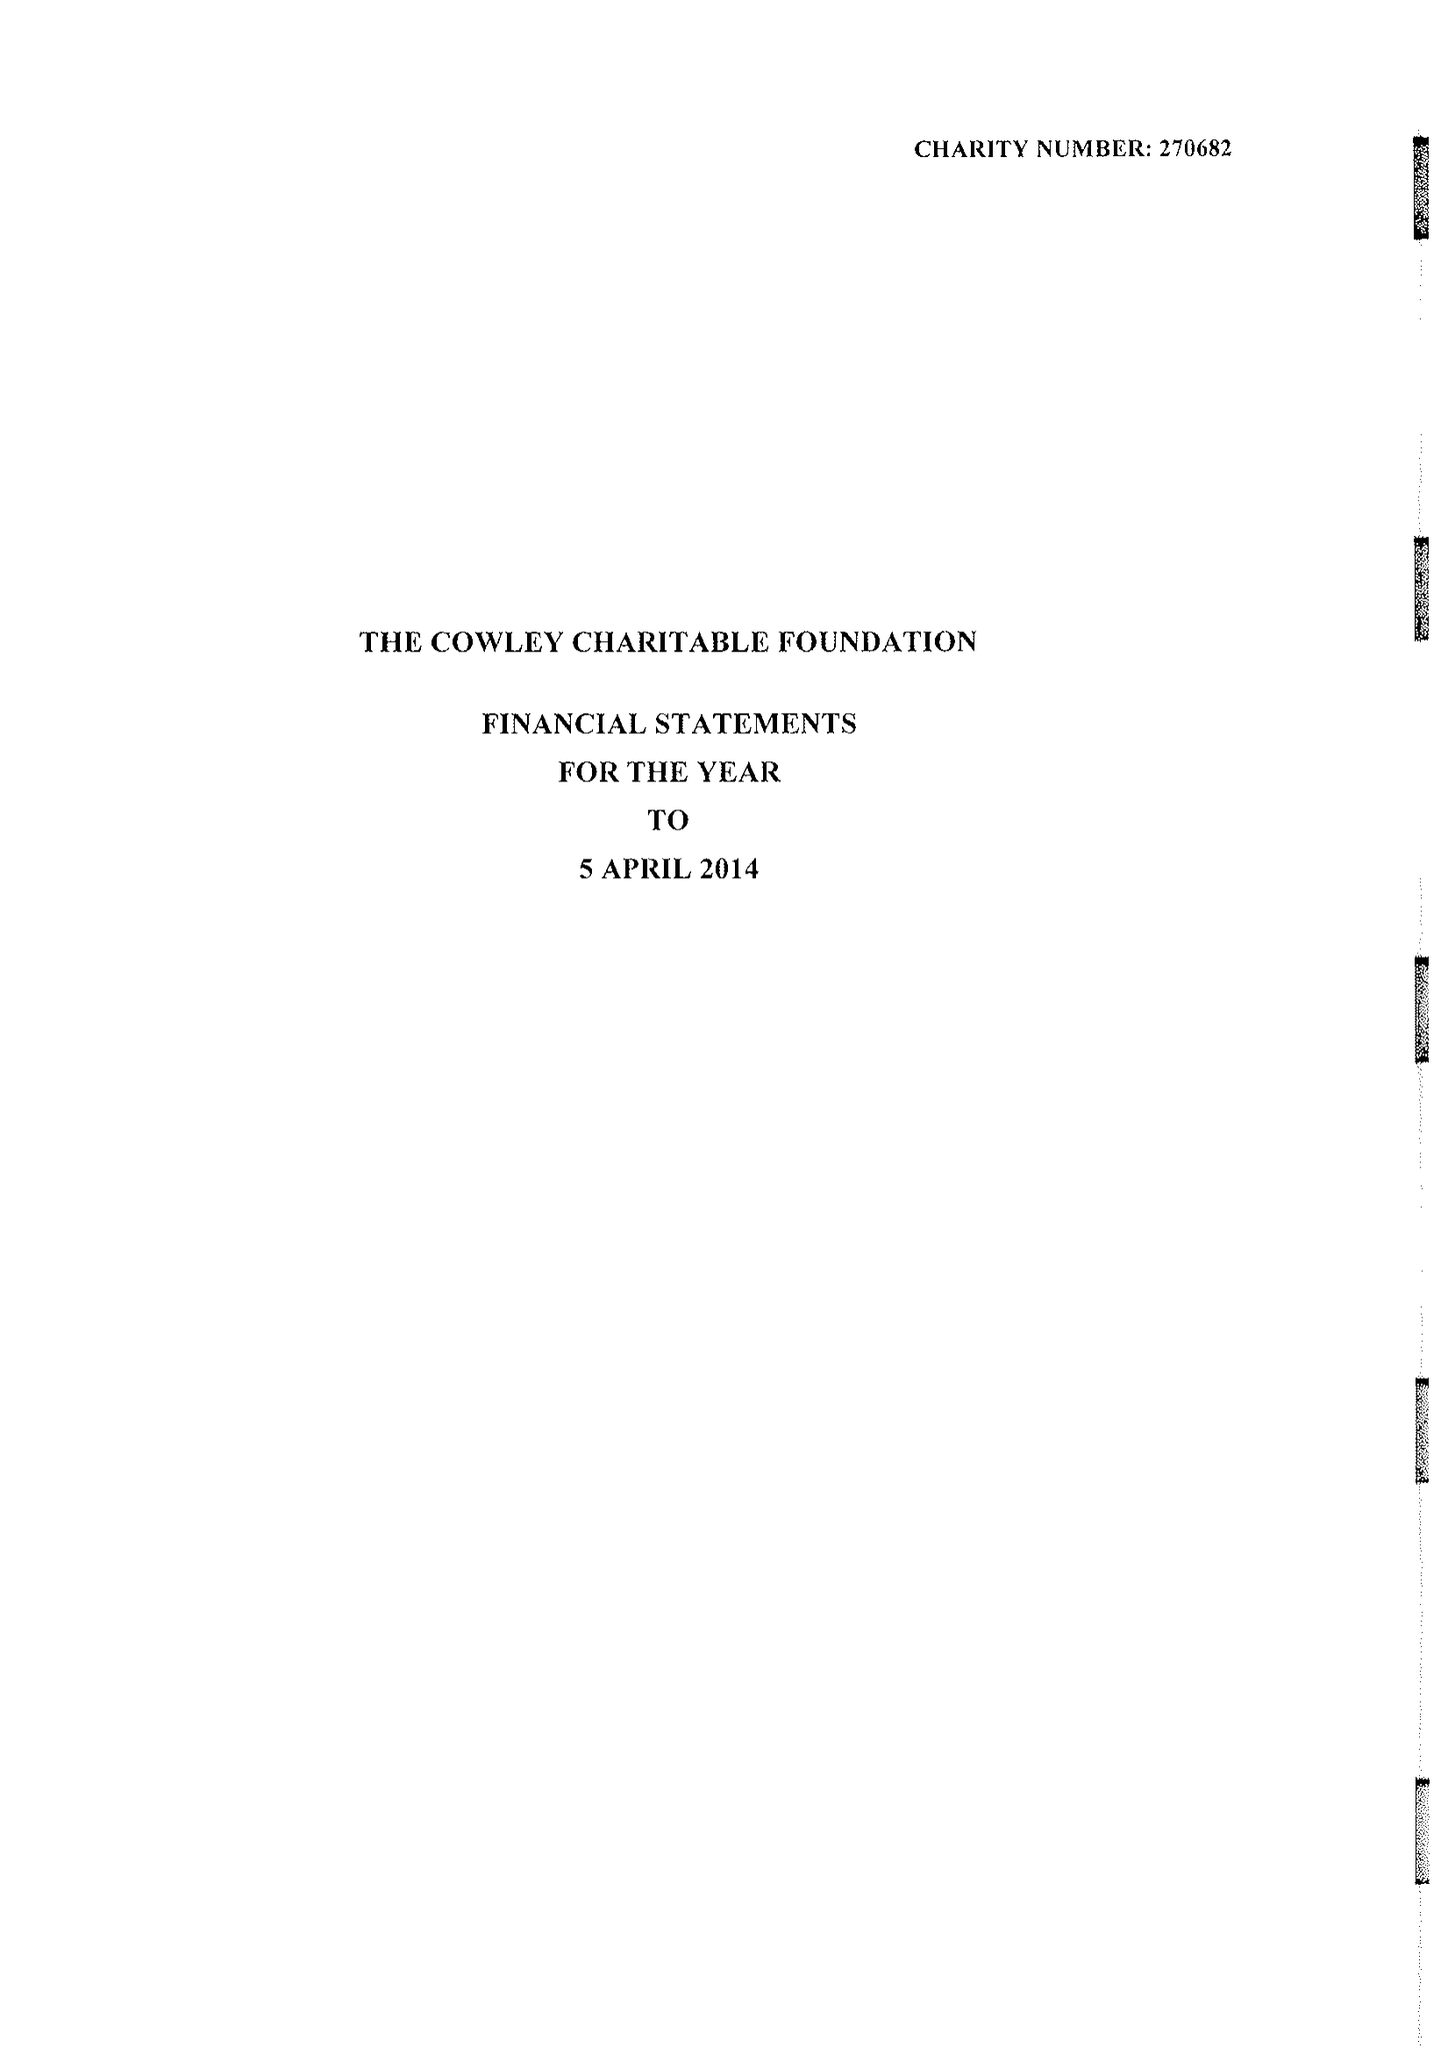What is the value for the address__street_line?
Answer the question using a single word or phrase. 17 GROSVENOR GARDENS 